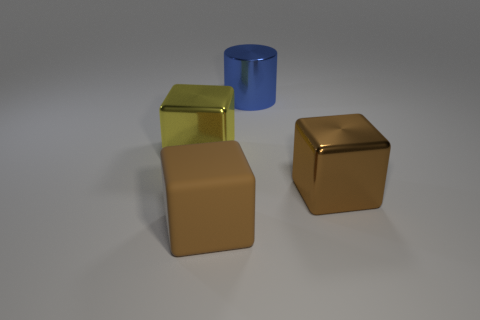What number of other objects are there of the same size as the yellow thing?
Your answer should be compact. 3. What number of objects are blocks that are to the right of the big yellow metallic cube or shiny objects left of the large brown matte cube?
Your answer should be compact. 3. How many other metallic objects are the same shape as the large yellow metal thing?
Provide a succinct answer. 1. What is the large block that is both behind the large rubber block and to the right of the big yellow cube made of?
Give a very brief answer. Metal. How many objects are on the left side of the large metal cylinder?
Make the answer very short. 2. How many rubber cubes are there?
Your answer should be compact. 1. Is the blue cylinder the same size as the yellow shiny cube?
Offer a very short reply. Yes. There is a brown block that is on the right side of the cube that is in front of the brown metallic cube; are there any big brown rubber blocks that are on the right side of it?
Give a very brief answer. No. There is a big yellow object that is the same shape as the brown rubber thing; what is its material?
Offer a very short reply. Metal. The metallic cube to the right of the big blue metal object is what color?
Offer a terse response. Brown. 